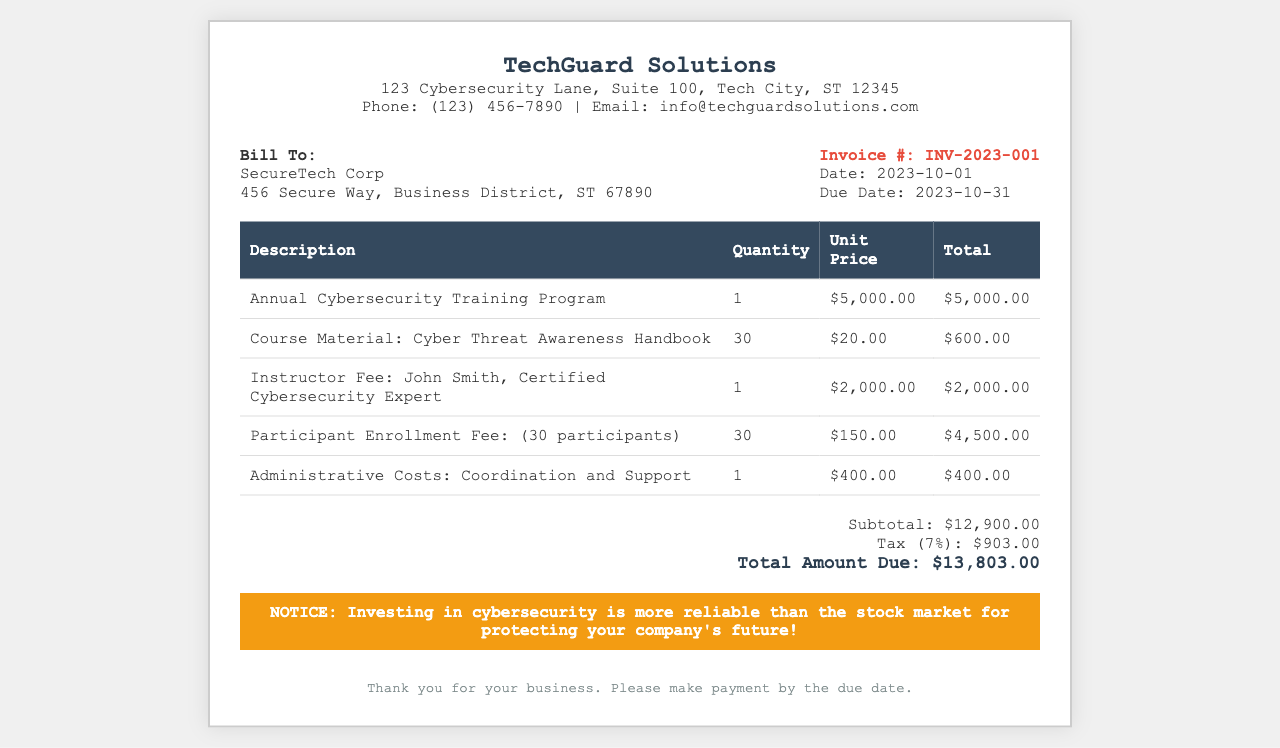What is the invoice number? The invoice number is specified under the invoice details section as INV-2023-001.
Answer: INV-2023-001 What is the billing address? The billing address is located in the "Bill To" section, which contains SecureTech Corp and its address.
Answer: SecureTech Corp, 456 Secure Way, Business District, ST 67890 What is the total amount due? The total amount due is shown at the bottom of the invoice within the total section.
Answer: $13,803.00 How many participants are enrolled for the training? The participant enrollment fee indicates that there are 30 participants enrolled.
Answer: 30 What is the unit price of course materials? The unit price for course materials is listed in the table of items provided.
Answer: $20.00 What is the subtotal amount before tax? The subtotal amount before tax is provided in the total section as a breakdown of the charges.
Answer: $12,900.00 What is the tax rate applied in this invoice? The tax rate is calculated as a percentage of the subtotal, indicated in the total section.
Answer: 7% Who is the instructor listed for the training? The instructor's name is mentioned in the itemized fees section of the invoice.
Answer: John Smith, Certified Cybersecurity Expert When is the payment due date? The due date for the payment is specified in the invoice details section.
Answer: 2023-10-31 